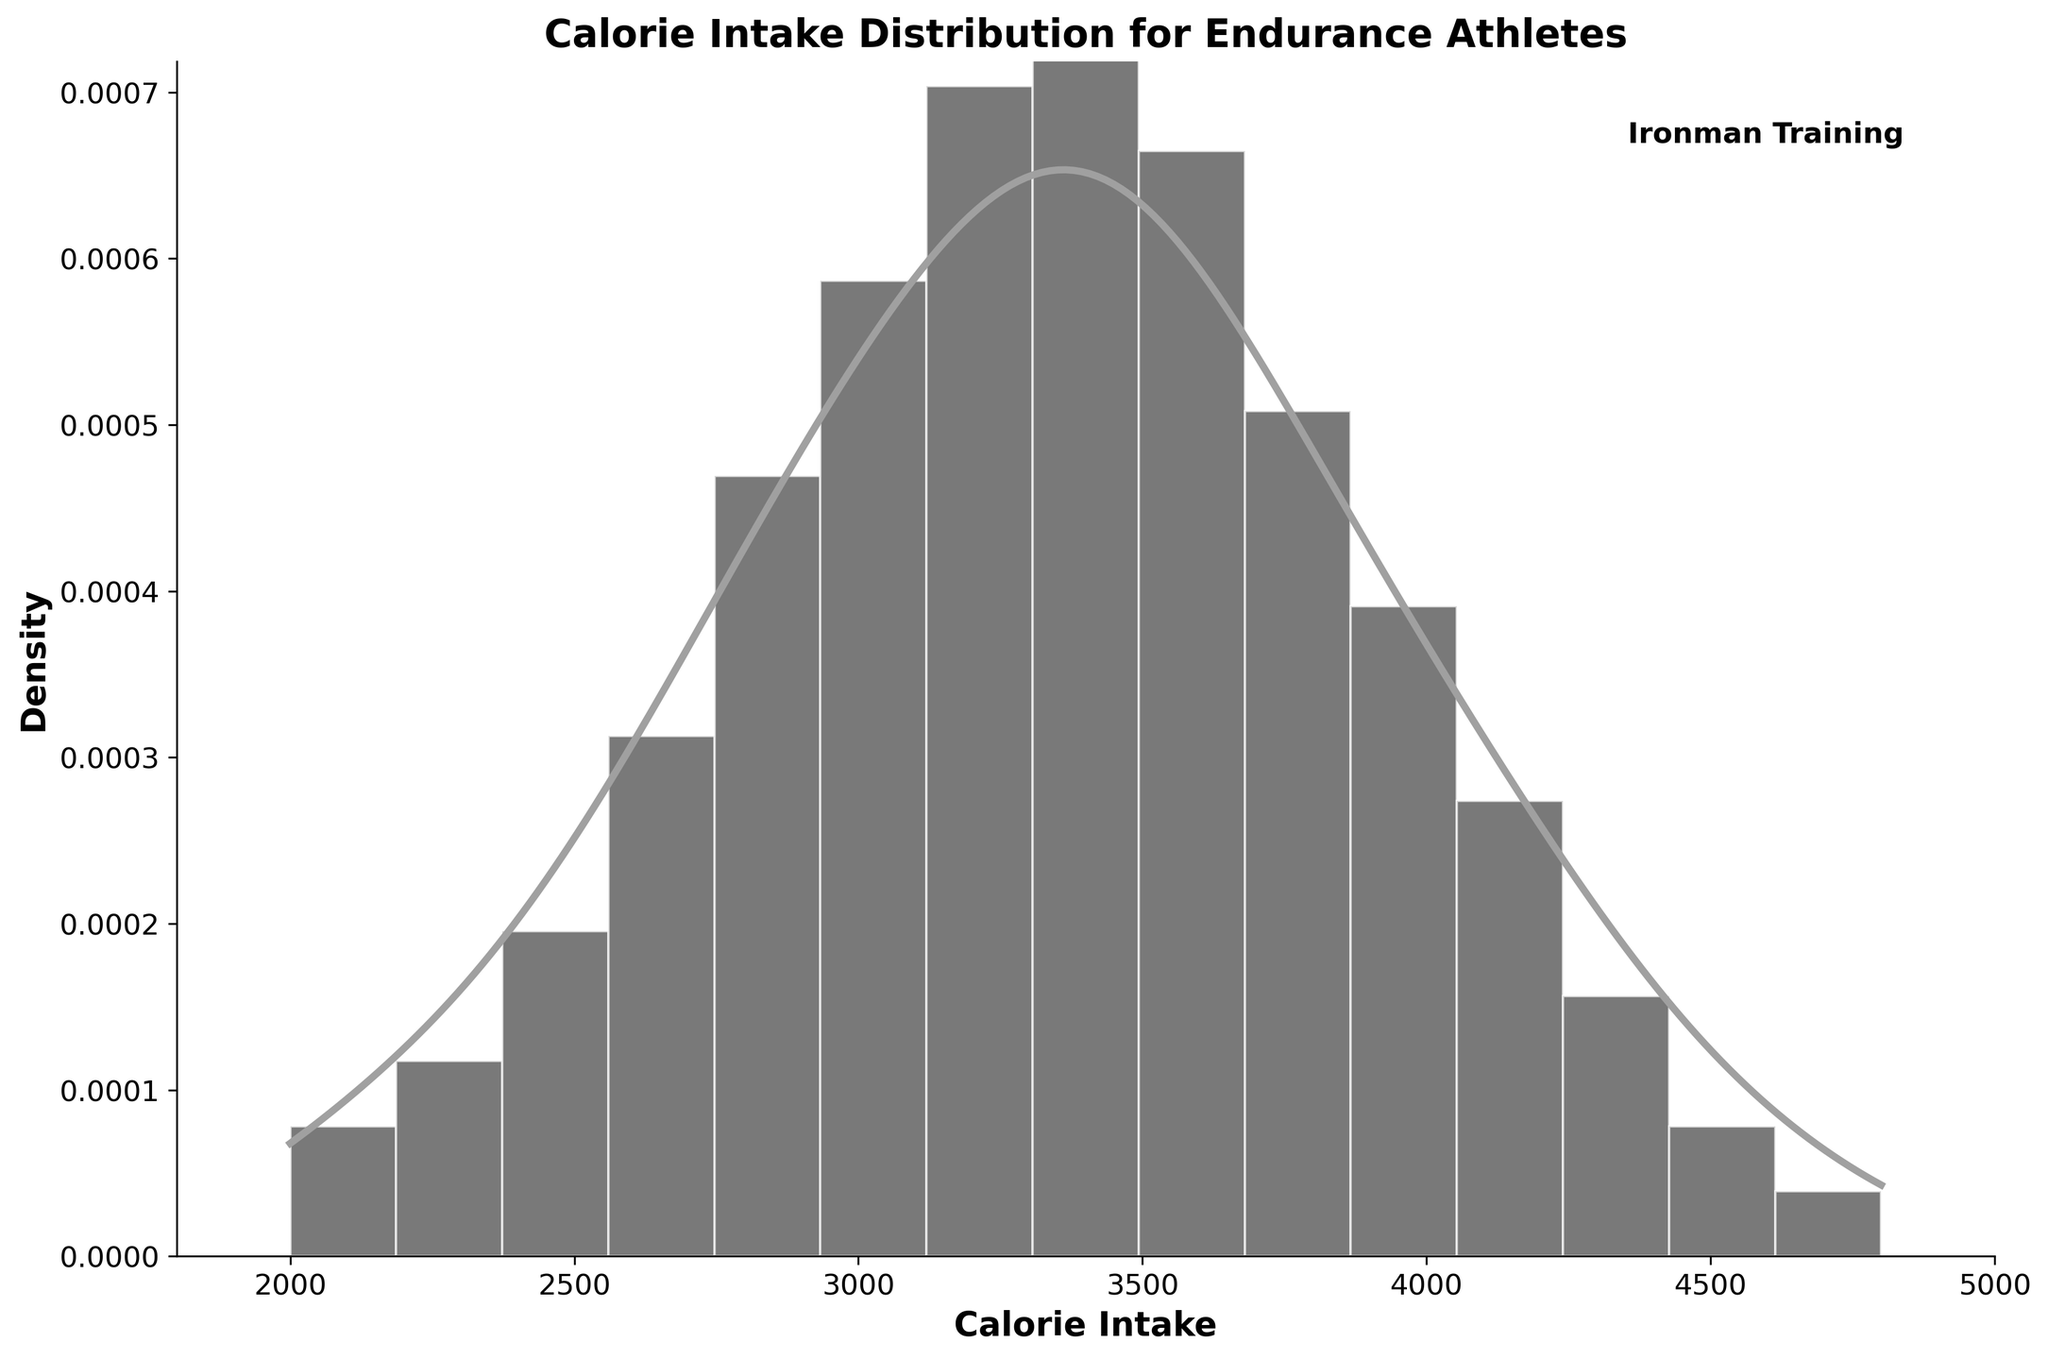What is the title of the histogram with KDE plot? The title is usually displayed at the top of the plot. It reads, "Calorie Intake Distribution for Endurance Athletes".
Answer: Calorie Intake Distribution for Endurance Athletes What does the x-axis represent? The x-axis label indicates what is being measured horizontally. It represents "Calorie Intake".
Answer: Calorie Intake How many peaks are observed in the KDE curve? By looking at the KDE (density) curve on the plot, identify the number of high points. There is a single smooth peak in the KDE curve.
Answer: 1 Within what range do the majority of the calorie intake values fall? Observe the histogram bars and KDE curve, focusing on where most of the values are concentrated. Most values are between 2800 and 3600 calories.
Answer: 2800 to 3600 calories Is there a specific caloric intake value where the peak of the density curve is? Find the highest point on the KDE curve and identify the corresponding x-axis value. The peak of the KDE curve is around 3400 calories.
Answer: 3400 calories Which calorie intake range has the least frequency? Identify the bins with the least height in the histogram. The least frequent ranges are at the extremes: 2000, 2200, 4600, and 4800 calories.
Answer: 2000, 2200, 4600, 4800 calories What can you infer about the calorie intake pattern of endurance athletes during intense training periods based on this plot? Analyze the overall distribution shape, the KDE, and histogram to draw a conclusion. The distribution shows a concentration around 3200 to 3600 calories, indicating this is a typical intake range, with very few athletes consuming extreme low or high values outside this range.
Answer: Most athletes consume between 3200 to 3600 calories What is the highest density value observed on the KDE curve? Look at the y-axis value corresponding to the peak of the KDE curve. The highest density value is approximately 0.001.
Answer: 0.001 Compare the frequency of athletes consuming 3000 calories to those consuming 3800 calories. Which is higher? Observe the height of histogram bars at 3000 and 3800 calories. The bar at 3000 calories is higher than at 3800 calories.
Answer: 3000 calories What does the density represent in this plot? Density on the y-axis represents the probability density function, showing how calorie intake values are distributed across the range.
Answer: Probability density 